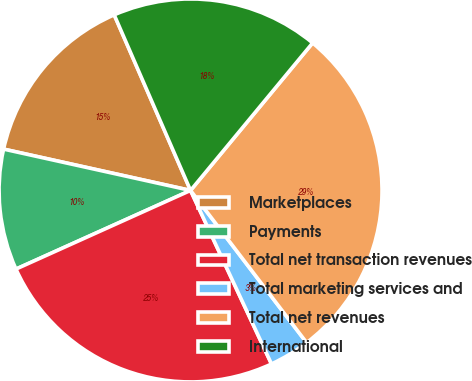Convert chart to OTSL. <chart><loc_0><loc_0><loc_500><loc_500><pie_chart><fcel>Marketplaces<fcel>Payments<fcel>Total net transaction revenues<fcel>Total marketing services and<fcel>Total net revenues<fcel>International<nl><fcel>15.01%<fcel>10.2%<fcel>25.21%<fcel>3.42%<fcel>28.63%<fcel>17.53%<nl></chart> 